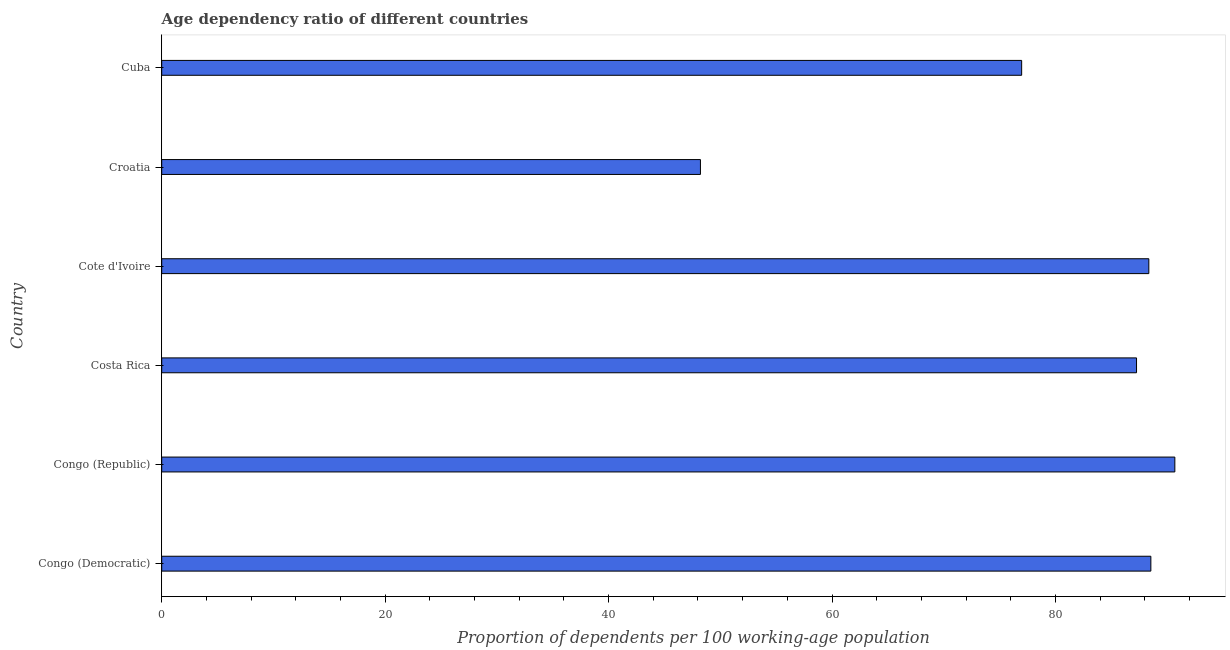Does the graph contain any zero values?
Give a very brief answer. No. What is the title of the graph?
Your response must be concise. Age dependency ratio of different countries. What is the label or title of the X-axis?
Keep it short and to the point. Proportion of dependents per 100 working-age population. What is the age dependency ratio in Croatia?
Make the answer very short. 48.22. Across all countries, what is the maximum age dependency ratio?
Your answer should be very brief. 90.68. Across all countries, what is the minimum age dependency ratio?
Offer a terse response. 48.22. In which country was the age dependency ratio maximum?
Provide a succinct answer. Congo (Republic). In which country was the age dependency ratio minimum?
Your answer should be very brief. Croatia. What is the sum of the age dependency ratio?
Offer a terse response. 480.03. What is the difference between the age dependency ratio in Costa Rica and Cote d'Ivoire?
Make the answer very short. -1.1. What is the average age dependency ratio per country?
Your response must be concise. 80. What is the median age dependency ratio?
Provide a succinct answer. 87.81. In how many countries, is the age dependency ratio greater than 84 ?
Provide a succinct answer. 4. What is the ratio of the age dependency ratio in Cote d'Ivoire to that in Cuba?
Provide a succinct answer. 1.15. Is the age dependency ratio in Congo (Democratic) less than that in Cote d'Ivoire?
Give a very brief answer. No. What is the difference between the highest and the second highest age dependency ratio?
Offer a very short reply. 2.15. Is the sum of the age dependency ratio in Costa Rica and Cote d'Ivoire greater than the maximum age dependency ratio across all countries?
Make the answer very short. Yes. What is the difference between the highest and the lowest age dependency ratio?
Make the answer very short. 42.46. In how many countries, is the age dependency ratio greater than the average age dependency ratio taken over all countries?
Give a very brief answer. 4. Are all the bars in the graph horizontal?
Make the answer very short. Yes. What is the Proportion of dependents per 100 working-age population of Congo (Democratic)?
Your answer should be compact. 88.54. What is the Proportion of dependents per 100 working-age population in Congo (Republic)?
Keep it short and to the point. 90.68. What is the Proportion of dependents per 100 working-age population in Costa Rica?
Provide a short and direct response. 87.26. What is the Proportion of dependents per 100 working-age population of Cote d'Ivoire?
Your answer should be compact. 88.36. What is the Proportion of dependents per 100 working-age population in Croatia?
Offer a very short reply. 48.22. What is the Proportion of dependents per 100 working-age population in Cuba?
Provide a short and direct response. 76.97. What is the difference between the Proportion of dependents per 100 working-age population in Congo (Democratic) and Congo (Republic)?
Ensure brevity in your answer.  -2.15. What is the difference between the Proportion of dependents per 100 working-age population in Congo (Democratic) and Costa Rica?
Provide a short and direct response. 1.28. What is the difference between the Proportion of dependents per 100 working-age population in Congo (Democratic) and Cote d'Ivoire?
Your response must be concise. 0.18. What is the difference between the Proportion of dependents per 100 working-age population in Congo (Democratic) and Croatia?
Give a very brief answer. 40.32. What is the difference between the Proportion of dependents per 100 working-age population in Congo (Democratic) and Cuba?
Offer a very short reply. 11.56. What is the difference between the Proportion of dependents per 100 working-age population in Congo (Republic) and Costa Rica?
Your answer should be very brief. 3.43. What is the difference between the Proportion of dependents per 100 working-age population in Congo (Republic) and Cote d'Ivoire?
Your response must be concise. 2.33. What is the difference between the Proportion of dependents per 100 working-age population in Congo (Republic) and Croatia?
Your answer should be very brief. 42.46. What is the difference between the Proportion of dependents per 100 working-age population in Congo (Republic) and Cuba?
Your response must be concise. 13.71. What is the difference between the Proportion of dependents per 100 working-age population in Costa Rica and Cote d'Ivoire?
Your response must be concise. -1.1. What is the difference between the Proportion of dependents per 100 working-age population in Costa Rica and Croatia?
Provide a succinct answer. 39.04. What is the difference between the Proportion of dependents per 100 working-age population in Costa Rica and Cuba?
Your response must be concise. 10.28. What is the difference between the Proportion of dependents per 100 working-age population in Cote d'Ivoire and Croatia?
Offer a very short reply. 40.14. What is the difference between the Proportion of dependents per 100 working-age population in Cote d'Ivoire and Cuba?
Your answer should be very brief. 11.38. What is the difference between the Proportion of dependents per 100 working-age population in Croatia and Cuba?
Offer a very short reply. -28.75. What is the ratio of the Proportion of dependents per 100 working-age population in Congo (Democratic) to that in Congo (Republic)?
Your answer should be compact. 0.98. What is the ratio of the Proportion of dependents per 100 working-age population in Congo (Democratic) to that in Costa Rica?
Provide a succinct answer. 1.01. What is the ratio of the Proportion of dependents per 100 working-age population in Congo (Democratic) to that in Cote d'Ivoire?
Provide a succinct answer. 1. What is the ratio of the Proportion of dependents per 100 working-age population in Congo (Democratic) to that in Croatia?
Give a very brief answer. 1.84. What is the ratio of the Proportion of dependents per 100 working-age population in Congo (Democratic) to that in Cuba?
Provide a succinct answer. 1.15. What is the ratio of the Proportion of dependents per 100 working-age population in Congo (Republic) to that in Costa Rica?
Your answer should be compact. 1.04. What is the ratio of the Proportion of dependents per 100 working-age population in Congo (Republic) to that in Cote d'Ivoire?
Keep it short and to the point. 1.03. What is the ratio of the Proportion of dependents per 100 working-age population in Congo (Republic) to that in Croatia?
Ensure brevity in your answer.  1.88. What is the ratio of the Proportion of dependents per 100 working-age population in Congo (Republic) to that in Cuba?
Provide a short and direct response. 1.18. What is the ratio of the Proportion of dependents per 100 working-age population in Costa Rica to that in Croatia?
Offer a terse response. 1.81. What is the ratio of the Proportion of dependents per 100 working-age population in Costa Rica to that in Cuba?
Give a very brief answer. 1.13. What is the ratio of the Proportion of dependents per 100 working-age population in Cote d'Ivoire to that in Croatia?
Offer a terse response. 1.83. What is the ratio of the Proportion of dependents per 100 working-age population in Cote d'Ivoire to that in Cuba?
Offer a terse response. 1.15. What is the ratio of the Proportion of dependents per 100 working-age population in Croatia to that in Cuba?
Your response must be concise. 0.63. 